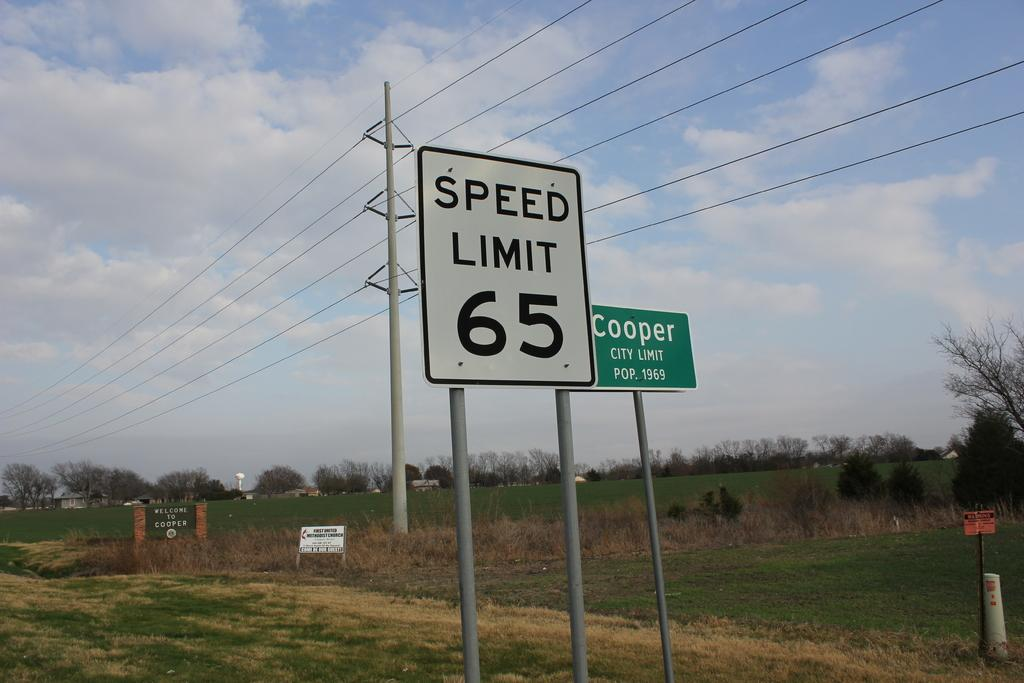<image>
Provide a brief description of the given image. A street sign designates the speed limit to be sixty five. 